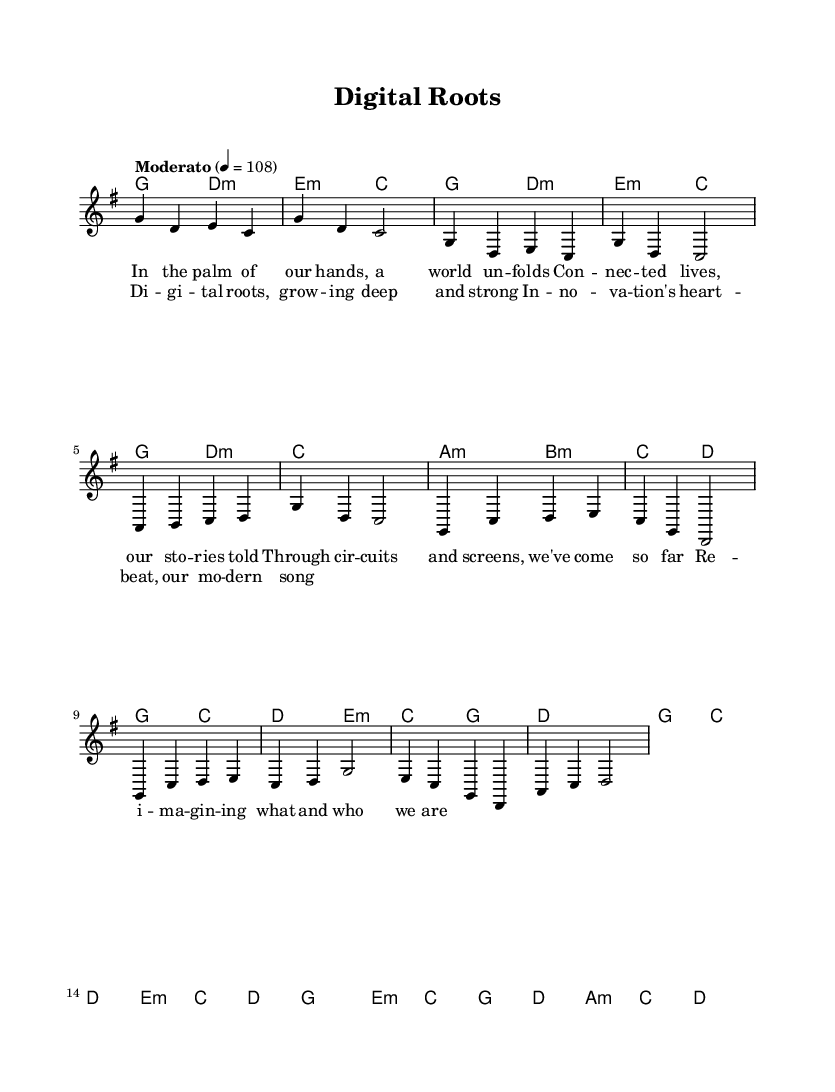What is the key signature of this music? The key signature is G major, which contains one sharp (F#).
Answer: G major What is the time signature of this piece? The time signature is 4/4, which indicates four beats per measure.
Answer: 4/4 What is the tempo marking for this piece? The tempo marking is "Moderato," which typically suggests a moderate pace.
Answer: Moderato How many measures are in the verse? The verse consists of four measures, as indicated by the group of notes in that section.
Answer: Four Which chords are used in the chorus? The chorus employs G, C, D, and E minor chords as indicated in the harmonies below the melody.
Answer: G, C, D, E minor What themes are reflected in the lyrics of the song? The lyrics reflect themes of connection, technology, and self-discovery in a modern context through digital means.
Answer: Connection, technology, self-discovery Is this piece primarily for solo voice or ensemble? This piece is primarily written for solo voice, as indicated by the single "lead" voice part in the score.
Answer: Solo voice 